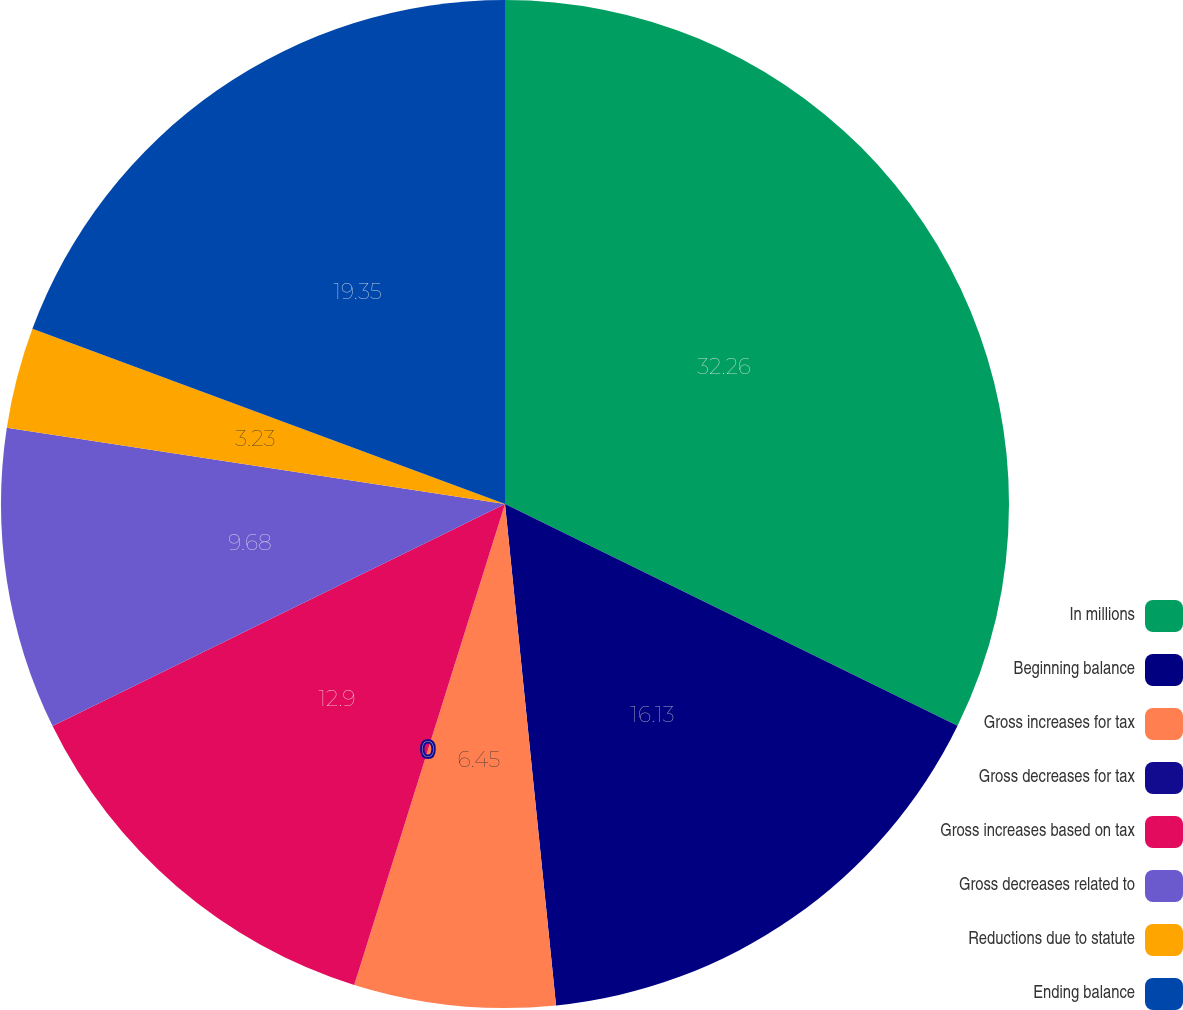<chart> <loc_0><loc_0><loc_500><loc_500><pie_chart><fcel>In millions<fcel>Beginning balance<fcel>Gross increases for tax<fcel>Gross decreases for tax<fcel>Gross increases based on tax<fcel>Gross decreases related to<fcel>Reductions due to statute<fcel>Ending balance<nl><fcel>32.25%<fcel>16.13%<fcel>6.45%<fcel>0.0%<fcel>12.9%<fcel>9.68%<fcel>3.23%<fcel>19.35%<nl></chart> 